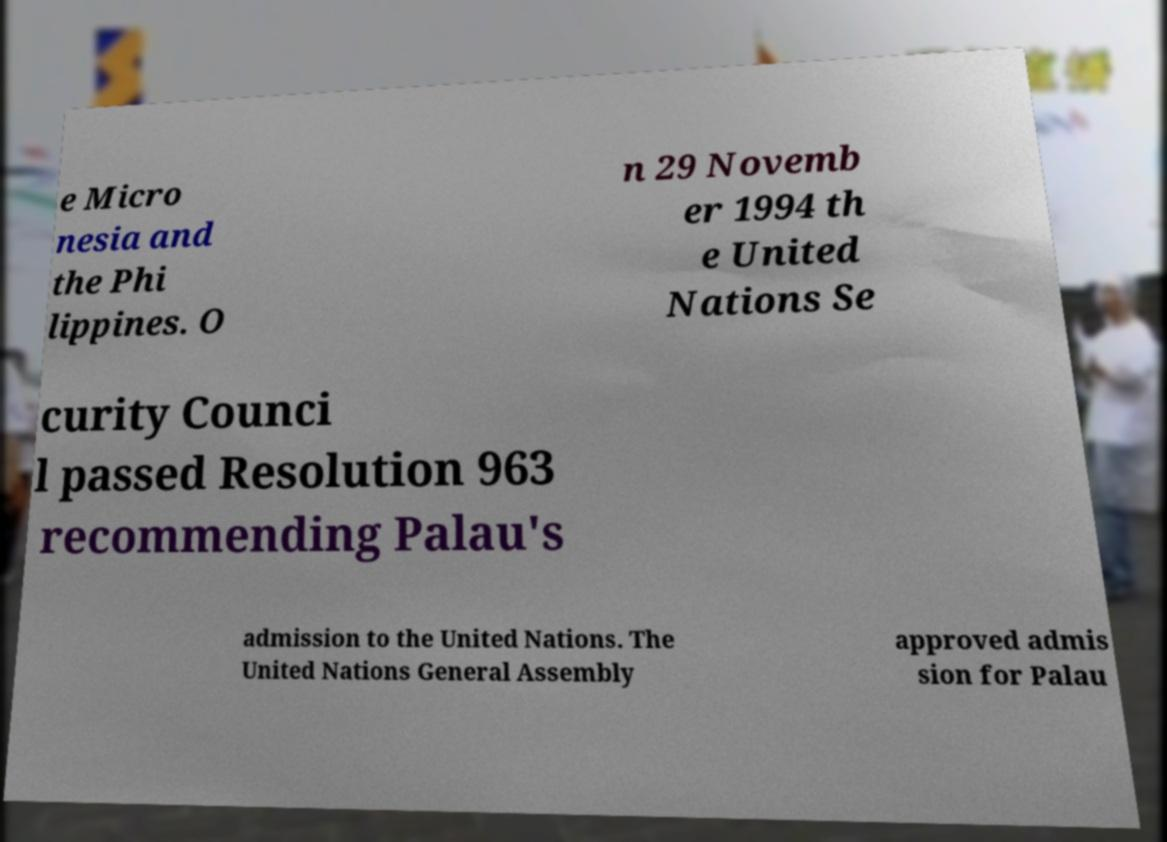Please read and relay the text visible in this image. What does it say? e Micro nesia and the Phi lippines. O n 29 Novemb er 1994 th e United Nations Se curity Counci l passed Resolution 963 recommending Palau's admission to the United Nations. The United Nations General Assembly approved admis sion for Palau 